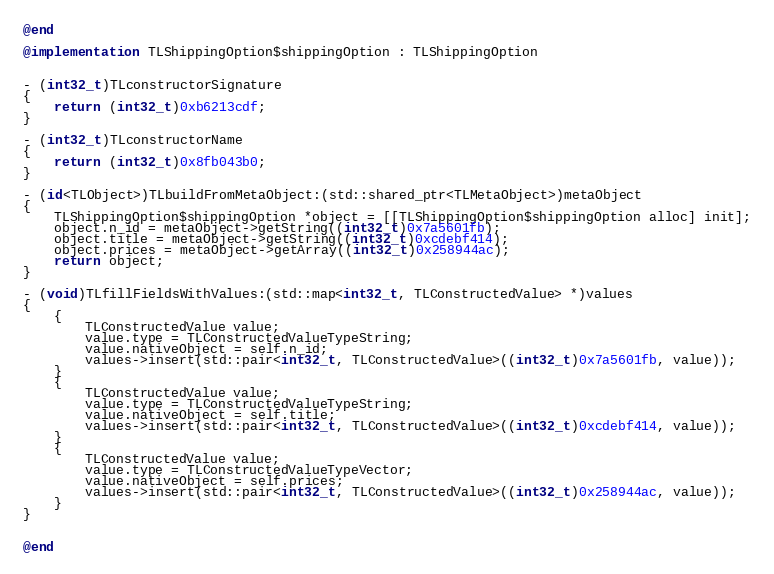Convert code to text. <code><loc_0><loc_0><loc_500><loc_500><_ObjectiveC_>@end

@implementation TLShippingOption$shippingOption : TLShippingOption


- (int32_t)TLconstructorSignature
{
    return (int32_t)0xb6213cdf;
}

- (int32_t)TLconstructorName
{
    return (int32_t)0x8fb043b0;
}

- (id<TLObject>)TLbuildFromMetaObject:(std::shared_ptr<TLMetaObject>)metaObject
{
    TLShippingOption$shippingOption *object = [[TLShippingOption$shippingOption alloc] init];
    object.n_id = metaObject->getString((int32_t)0x7a5601fb);
    object.title = metaObject->getString((int32_t)0xcdebf414);
    object.prices = metaObject->getArray((int32_t)0x258944ac);
    return object;
}

- (void)TLfillFieldsWithValues:(std::map<int32_t, TLConstructedValue> *)values
{
    {
        TLConstructedValue value;
        value.type = TLConstructedValueTypeString;
        value.nativeObject = self.n_id;
        values->insert(std::pair<int32_t, TLConstructedValue>((int32_t)0x7a5601fb, value));
    }
    {
        TLConstructedValue value;
        value.type = TLConstructedValueTypeString;
        value.nativeObject = self.title;
        values->insert(std::pair<int32_t, TLConstructedValue>((int32_t)0xcdebf414, value));
    }
    {
        TLConstructedValue value;
        value.type = TLConstructedValueTypeVector;
        value.nativeObject = self.prices;
        values->insert(std::pair<int32_t, TLConstructedValue>((int32_t)0x258944ac, value));
    }
}


@end

</code> 